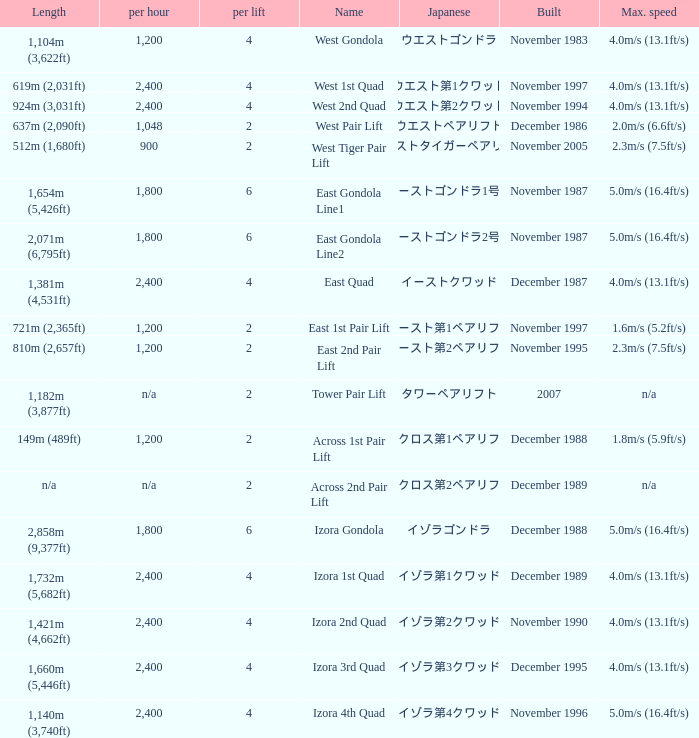How heavy is the  maximum 6.0. Write the full table. {'header': ['Length', 'per hour', 'per lift', 'Name', 'Japanese', 'Built', 'Max. speed'], 'rows': [['1,104m (3,622ft)', '1,200', '4', 'West Gondola', 'ウエストゴンドラ', 'November 1983', '4.0m/s (13.1ft/s)'], ['619m (2,031ft)', '2,400', '4', 'West 1st Quad', 'ウエスト第1クワッド', 'November 1997', '4.0m/s (13.1ft/s)'], ['924m (3,031ft)', '2,400', '4', 'West 2nd Quad', 'ウエスト第2クワッド', 'November 1994', '4.0m/s (13.1ft/s)'], ['637m (2,090ft)', '1,048', '2', 'West Pair Lift', 'ウエストペアリフト', 'December 1986', '2.0m/s (6.6ft/s)'], ['512m (1,680ft)', '900', '2', 'West Tiger Pair Lift', 'ウエストタイガーペアリフト', 'November 2005', '2.3m/s (7.5ft/s)'], ['1,654m (5,426ft)', '1,800', '6', 'East Gondola Line1', 'イーストゴンドラ1号線', 'November 1987', '5.0m/s (16.4ft/s)'], ['2,071m (6,795ft)', '1,800', '6', 'East Gondola Line2', 'イーストゴンドラ2号線', 'November 1987', '5.0m/s (16.4ft/s)'], ['1,381m (4,531ft)', '2,400', '4', 'East Quad', 'イーストクワッド', 'December 1987', '4.0m/s (13.1ft/s)'], ['721m (2,365ft)', '1,200', '2', 'East 1st Pair Lift', 'イースト第1ペアリフト', 'November 1997', '1.6m/s (5.2ft/s)'], ['810m (2,657ft)', '1,200', '2', 'East 2nd Pair Lift', 'イースト第2ペアリフト', 'November 1995', '2.3m/s (7.5ft/s)'], ['1,182m (3,877ft)', 'n/a', '2', 'Tower Pair Lift', 'タワーペアリフト', '2007', 'n/a'], ['149m (489ft)', '1,200', '2', 'Across 1st Pair Lift', 'アクロス第1ペアリフト', 'December 1988', '1.8m/s (5.9ft/s)'], ['n/a', 'n/a', '2', 'Across 2nd Pair Lift', 'アクロス第2ペアリフト', 'December 1989', 'n/a'], ['2,858m (9,377ft)', '1,800', '6', 'Izora Gondola', 'イゾラゴンドラ', 'December 1988', '5.0m/s (16.4ft/s)'], ['1,732m (5,682ft)', '2,400', '4', 'Izora 1st Quad', 'イゾラ第1クワッド', 'December 1989', '4.0m/s (13.1ft/s)'], ['1,421m (4,662ft)', '2,400', '4', 'Izora 2nd Quad', 'イゾラ第2クワッド', 'November 1990', '4.0m/s (13.1ft/s)'], ['1,660m (5,446ft)', '2,400', '4', 'Izora 3rd Quad', 'イゾラ第3クワッド', 'December 1995', '4.0m/s (13.1ft/s)'], ['1,140m (3,740ft)', '2,400', '4', 'Izora 4th Quad', 'イゾラ第4クワッド', 'November 1996', '5.0m/s (16.4ft/s)']]} 